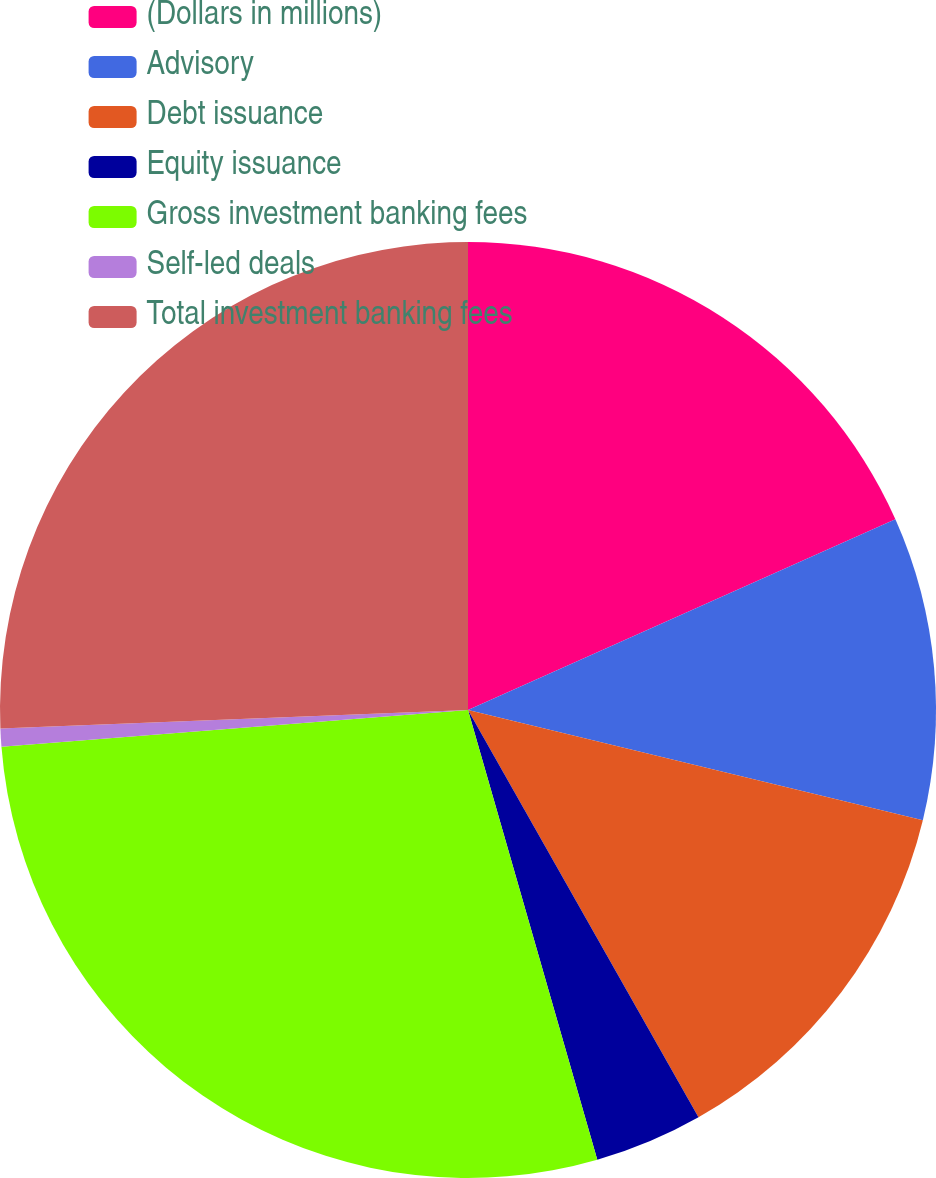<chart> <loc_0><loc_0><loc_500><loc_500><pie_chart><fcel>(Dollars in millions)<fcel>Advisory<fcel>Debt issuance<fcel>Equity issuance<fcel>Gross investment banking fees<fcel>Self-led deals<fcel>Total investment banking fees<nl><fcel>18.32%<fcel>10.46%<fcel>13.02%<fcel>3.74%<fcel>28.2%<fcel>0.62%<fcel>25.63%<nl></chart> 